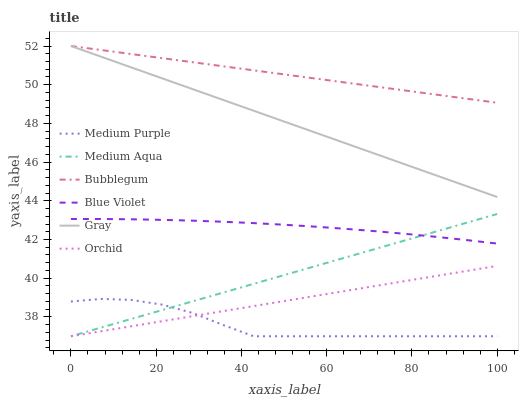Does Medium Purple have the minimum area under the curve?
Answer yes or no. Yes. Does Bubblegum have the maximum area under the curve?
Answer yes or no. Yes. Does Bubblegum have the minimum area under the curve?
Answer yes or no. No. Does Medium Purple have the maximum area under the curve?
Answer yes or no. No. Is Orchid the smoothest?
Answer yes or no. Yes. Is Medium Purple the roughest?
Answer yes or no. Yes. Is Bubblegum the smoothest?
Answer yes or no. No. Is Bubblegum the roughest?
Answer yes or no. No. Does Medium Purple have the lowest value?
Answer yes or no. Yes. Does Bubblegum have the lowest value?
Answer yes or no. No. Does Bubblegum have the highest value?
Answer yes or no. Yes. Does Medium Purple have the highest value?
Answer yes or no. No. Is Medium Purple less than Blue Violet?
Answer yes or no. Yes. Is Gray greater than Orchid?
Answer yes or no. Yes. Does Medium Aqua intersect Blue Violet?
Answer yes or no. Yes. Is Medium Aqua less than Blue Violet?
Answer yes or no. No. Is Medium Aqua greater than Blue Violet?
Answer yes or no. No. Does Medium Purple intersect Blue Violet?
Answer yes or no. No. 